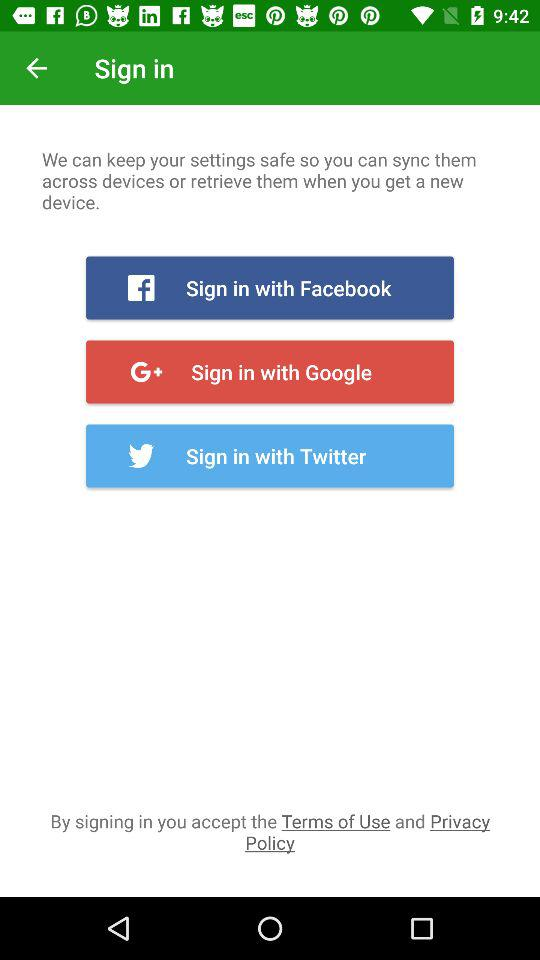Which application can we use to sign in? The applications are "Facebook", "Google" and "Twitter". 